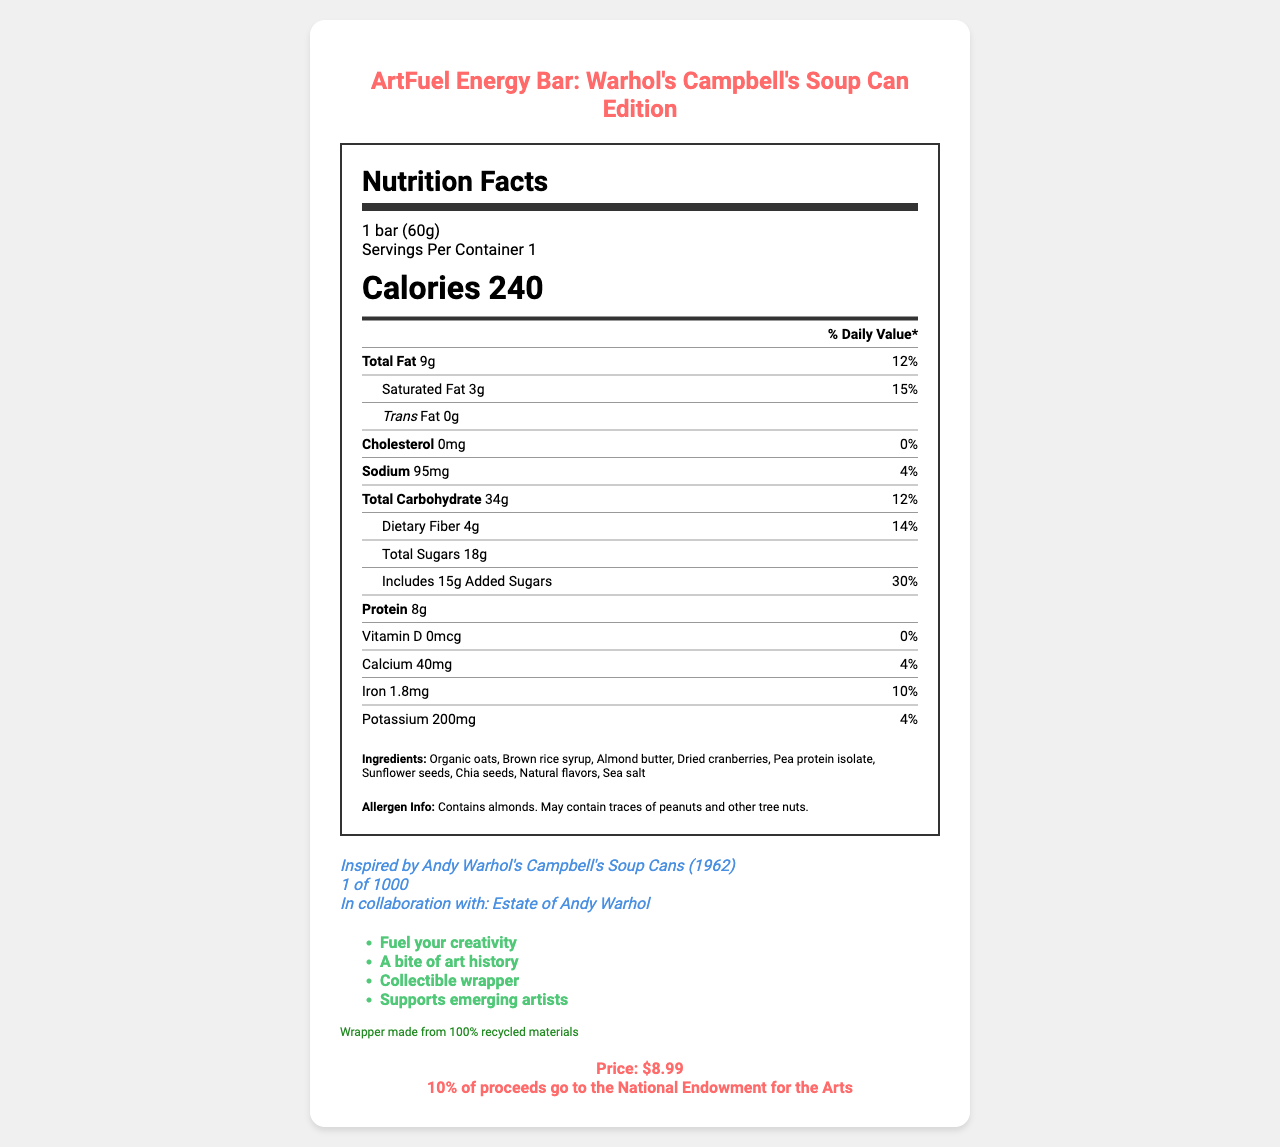what is the serving size of the ArtFuel Energy Bar? The serving size is clearly stated in the nutrition label section under the product title.
Answer: 1 bar (60g) how many grams of protein are in one serving of the energy bar? The protein content is listed in the nutrition label section.
Answer: 8g what is the percentage of Daily Value for added sugars? The percentage of Daily Value for added sugars is listed under the nutrient section for added sugars.
Answer: 30% which ingredient is listed first in the ingredients list? The ingredients list starts with "Organic oats."
Answer: Organic oats what donation is associated with each purchase of this energy bar? This information is found under the price-donation section at the bottom of the document.
Answer: 10% of proceeds go to the National Endowment for the Arts what famous artwork is featured on the wrapper of this energy bar? A. Mona Lisa B. The Starry Night C. Campbell's Soup Cans D. The Scream The document mentions that the wrapper design is inspired by Andy Warhol's Campbell's Soup Cans (1962).
Answer: C. Campbell's Soup Cans how much does one ArtFuel Energy Bar cost? The price is listed in the price-donation section.
Answer: $8.99 which of the following marketing claims is NOT made about the energy bar? I. Fuel your creativity II. Supports emerging artists III. High protein content IV. Collectible wrapper The marketing claims listed do not include "High protein content."
Answer: III. High protein content does this product contain any peanuts? The allergen information states that the bar contains almonds and may contain traces of peanuts and other tree nuts.
Answer: May contain traces of peanuts what is the main purpose of this document? This is a comprehensive summary of the entire document outlining its purpose and all the key points covered.
Answer: The document provides detailed information about the ArtFuel Energy Bar, including its nutritional content, ingredients, allergen information, artistic elements, marketing claims, sustainability info, price, and donation info. what is the expiration date of this energy bar? The document does not provide any details regarding the expiration date of the energy bar.
Answer: Not enough information how many grams of total carbohydrates does the energy bar contain? The amount of total carbohydrates is found in the nutrient section of the document.
Answer: 34g what is unique about the wrapper of the ArtFuel Energy Bar? This information is given under the artistic elements section.
Answer: It is inspired by Andy Warhol's Campbell's Soup Cans (1962) and is a limited edition (1 of 1000). how many servings are there per container? The serving information states that there is 1 serving per container for this energy bar.
Answer: 1 is there any cholesterol in the energy bar? The document specifies that the cholesterol amount is 0mg and the daily value is 0%.
Answer: No what is the sustainability claim made about the wrapper? The sustainability info section mentions that the wrapper is made from recycled materials.
Answer: Wrapper made from 100% recycled materials 